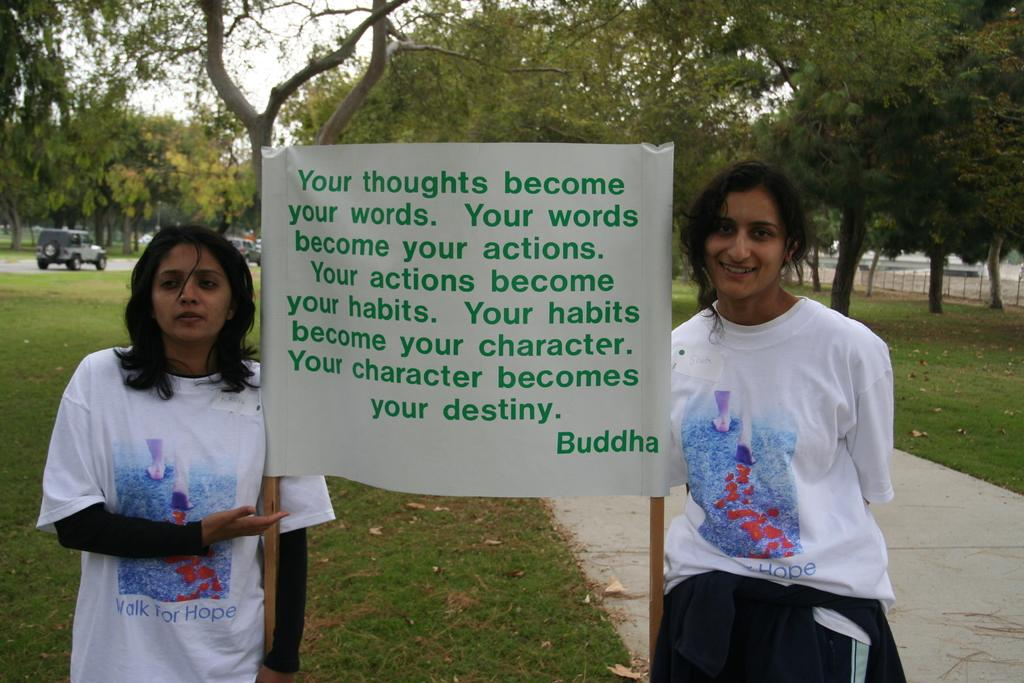Provide a one-sentence caption for the provided image. Two girls hold a poster with a quote from Buddha on it. 